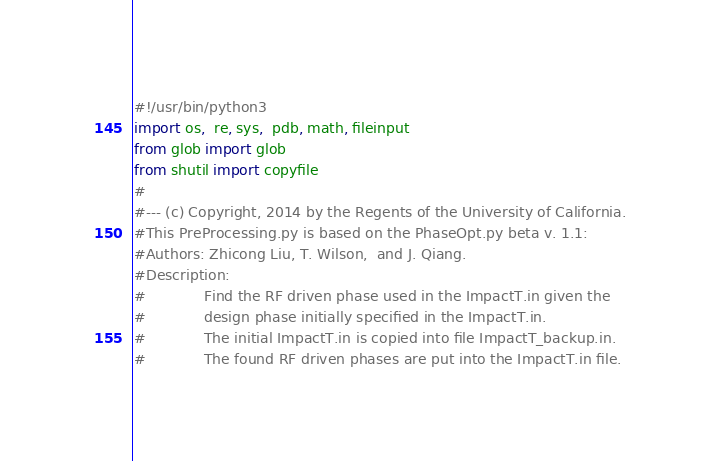<code> <loc_0><loc_0><loc_500><loc_500><_Python_>#!/usr/bin/python3
import os,  re, sys,  pdb, math, fileinput
from glob import glob
from shutil import copyfile
#
#--- (c) Copyright, 2014 by the Regents of the University of California.
#This PreProcessing.py is based on the PhaseOpt.py beta v. 1.1: 
#Authors: Zhicong Liu, T. Wilson,  and J. Qiang.
#Description: 
#             Find the RF driven phase used in the ImpactT.in given the
#             design phase initially specified in the ImpactT.in.
#             The initial ImpactT.in is copied into file ImpactT_backup.in.
#             The found RF driven phases are put into the ImpactT.in file.</code> 